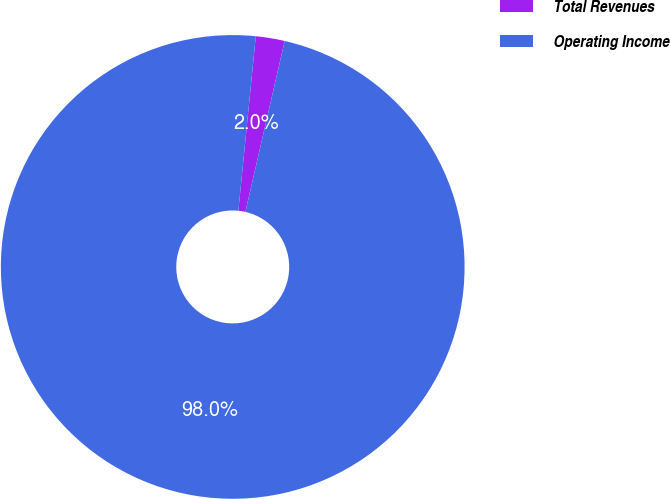Convert chart. <chart><loc_0><loc_0><loc_500><loc_500><pie_chart><fcel>Total Revenues<fcel>Operating Income<nl><fcel>2.01%<fcel>97.99%<nl></chart> 